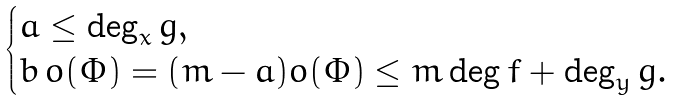Convert formula to latex. <formula><loc_0><loc_0><loc_500><loc_500>\begin{cases} a \leq \deg _ { x } g , \\ b \, o ( \Phi ) = ( m - a ) o ( \Phi ) \leq m \deg f + \deg _ { y } g . \end{cases}</formula> 